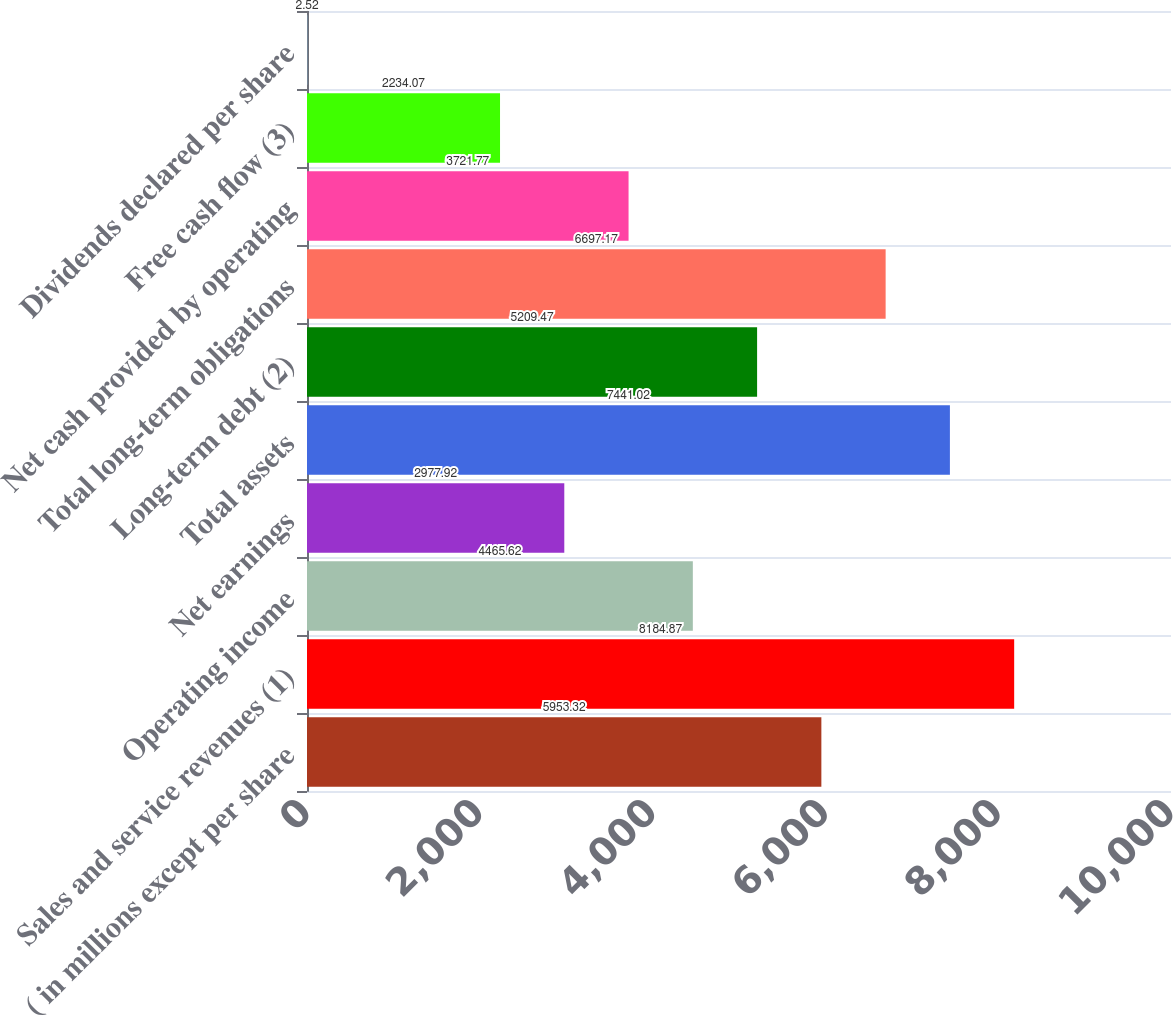Convert chart to OTSL. <chart><loc_0><loc_0><loc_500><loc_500><bar_chart><fcel>( in millions except per share<fcel>Sales and service revenues (1)<fcel>Operating income<fcel>Net earnings<fcel>Total assets<fcel>Long-term debt (2)<fcel>Total long-term obligations<fcel>Net cash provided by operating<fcel>Free cash flow (3)<fcel>Dividends declared per share<nl><fcel>5953.32<fcel>8184.87<fcel>4465.62<fcel>2977.92<fcel>7441.02<fcel>5209.47<fcel>6697.17<fcel>3721.77<fcel>2234.07<fcel>2.52<nl></chart> 